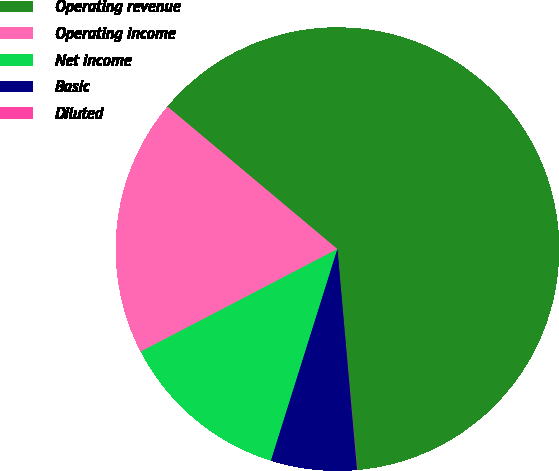Convert chart to OTSL. <chart><loc_0><loc_0><loc_500><loc_500><pie_chart><fcel>Operating revenue<fcel>Operating income<fcel>Net income<fcel>Basic<fcel>Diluted<nl><fcel>62.46%<fcel>18.75%<fcel>12.51%<fcel>6.26%<fcel>0.02%<nl></chart> 